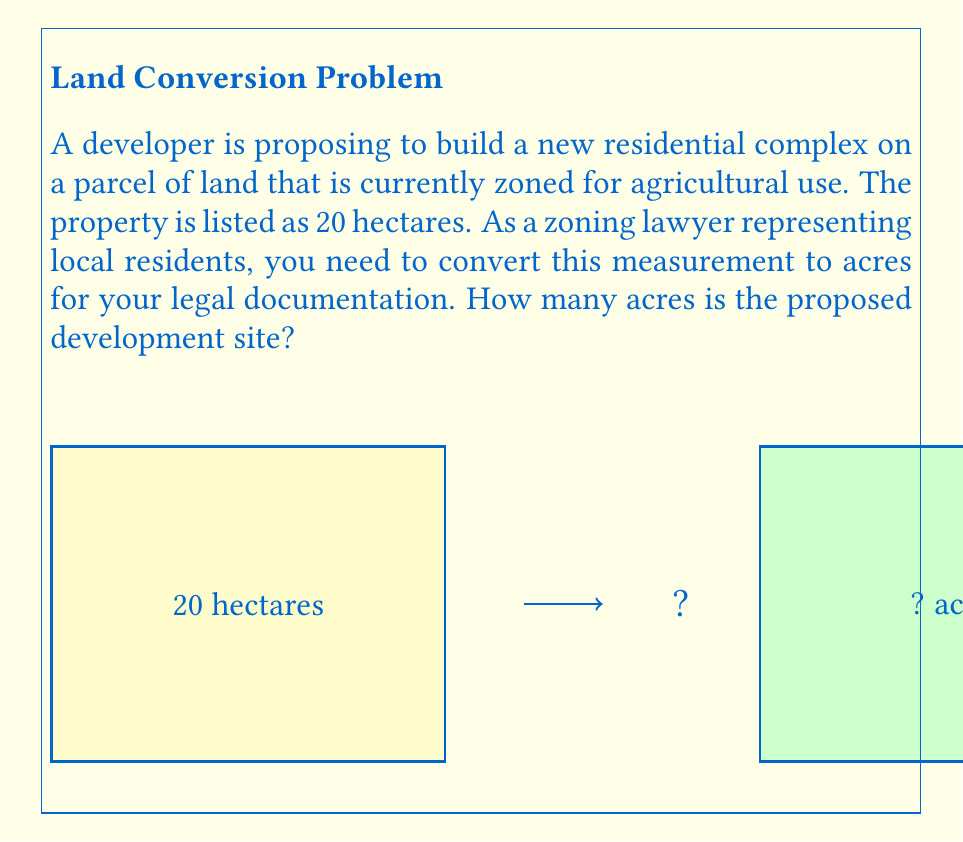Help me with this question. To convert hectares to acres, we need to use the conversion factor:

1 hectare = 2.47105 acres

Let's solve this step-by-step:

1) Set up the conversion equation:
   $$ x \text{ acres} = 20 \text{ hectares} \times \frac{2.47105 \text{ acres}}{1 \text{ hectare}} $$

2) Cancel out the units of hectares:
   $$ x \text{ acres} = 20 \times 2.47105 \text{ acres} $$

3) Multiply:
   $$ x = 20 \times 2.47105 = 49.421 \text{ acres} $$

4) Round to two decimal places for practical use:
   $$ x \approx 49.42 \text{ acres} $$

Therefore, the 20-hectare parcel is equivalent to approximately 49.42 acres.
Answer: 49.42 acres 